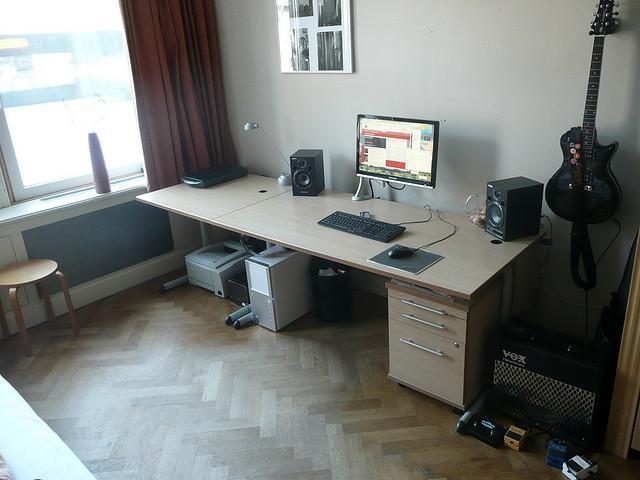What is the device on the floor under the desk near the wall?
Make your selection from the four choices given to correctly answer the question.
Options: Speaker, fax machine, computer tower, printer. Printer. 